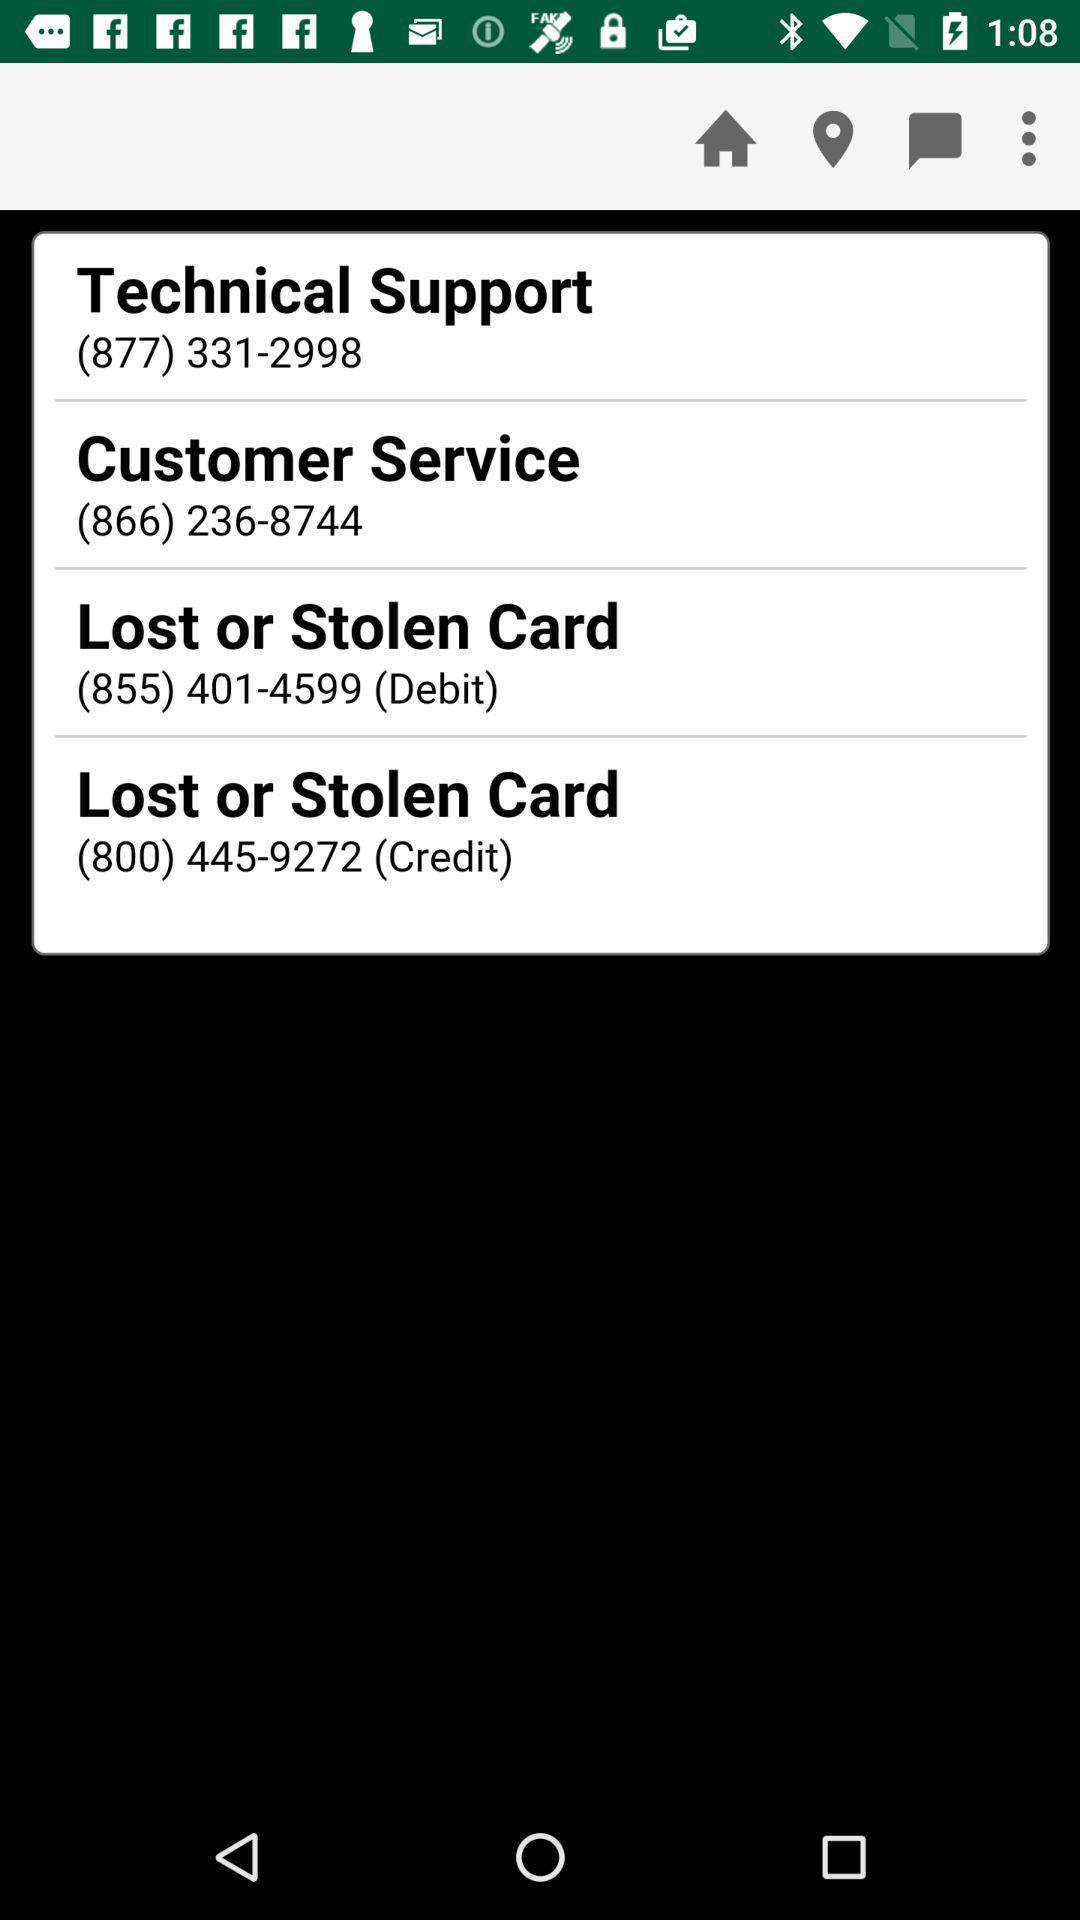What is the customer service contact number? The customer service contact number is (866) 236-8744. 